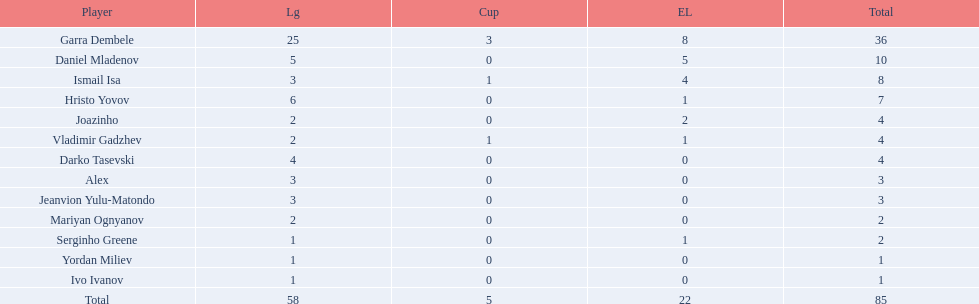How many goals did ismail isa score this season? 8. 